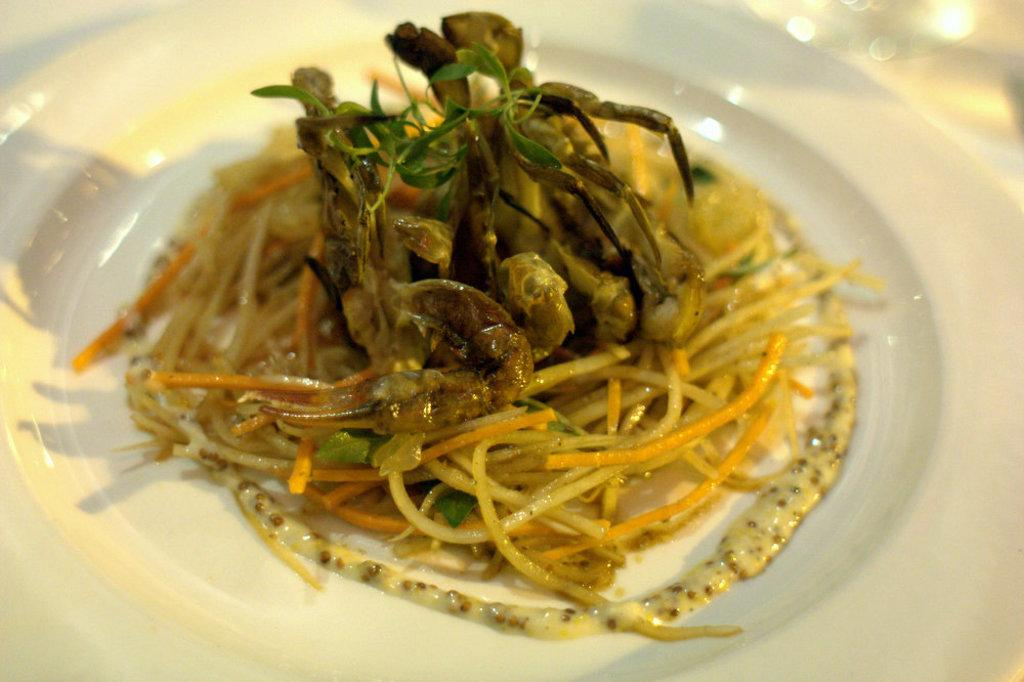What is on the plate in the image? There is a plate in the image, and it contains noodles and other food stuff. Can you describe the other food stuff in the plate? Unfortunately, the specific type of other food stuff is not mentioned in the provided facts. How many items are on the plate? There are at least two items on the plate: noodles and other food stuff. What type of coat is the person wearing in the image? There is no person or coat present in the image; it only features a plate with noodles and other food stuff. What is the name of the dish on the plate? The specific name of the dish is not mentioned in the provided facts. 